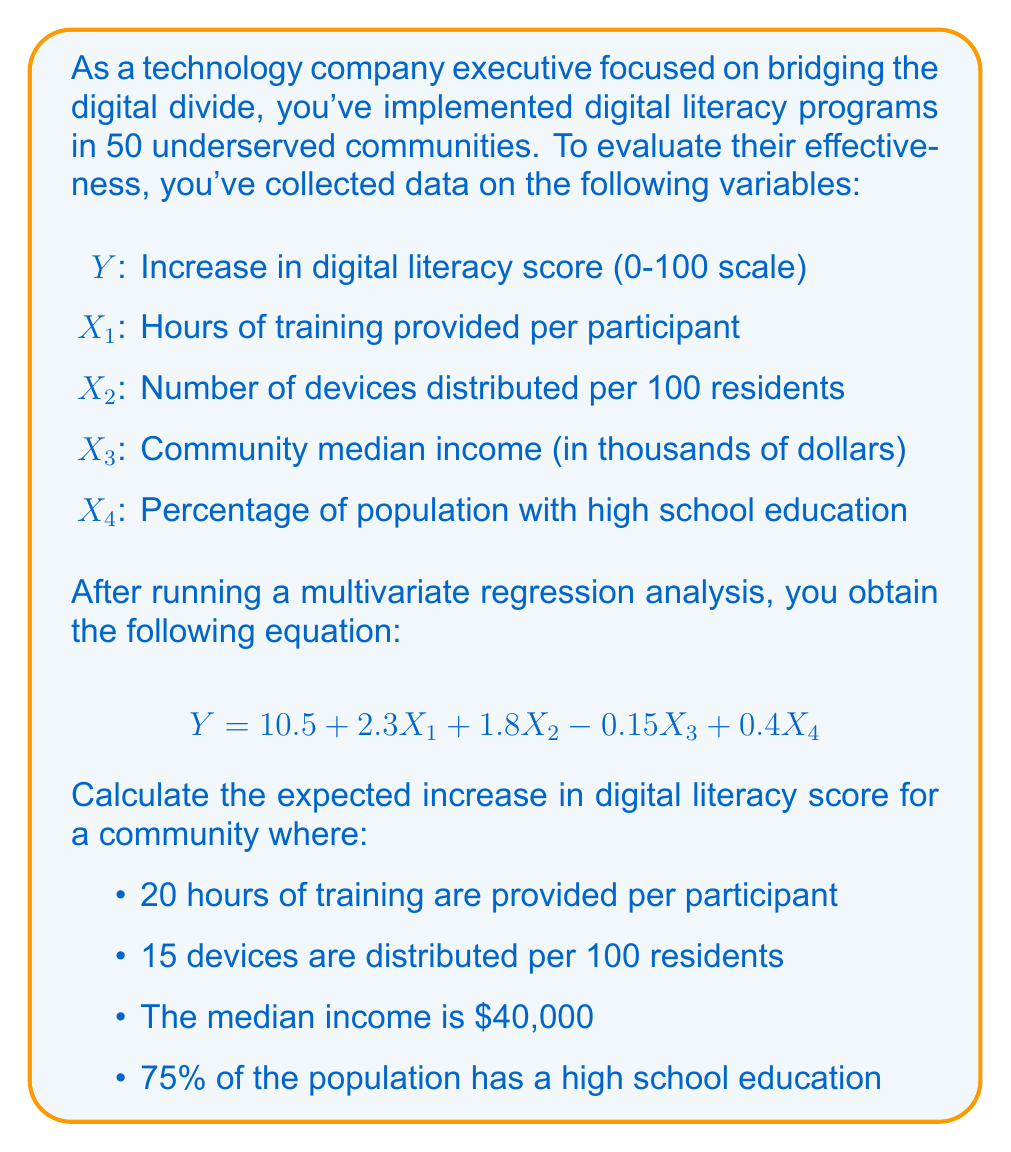Help me with this question. To solve this problem, we need to use the given multivariate regression equation and substitute the values for each variable. Let's break it down step by step:

1. The regression equation is:
   $$Y = 10.5 + 2.3X_1 + 1.8X_2 - 0.15X_3 + 0.4X_4$$

2. We have the following values:
   $X_1 = 20$ (hours of training)
   $X_2 = 15$ (devices per 100 residents)
   $X_3 = 40$ (median income in thousands)
   $X_4 = 75$ (percentage with high school education)

3. Let's substitute these values into the equation:

   $$Y = 10.5 + 2.3(20) + 1.8(15) - 0.15(40) + 0.4(75)$$

4. Now, let's calculate each term:
   - $10.5$ (constant term)
   - $2.3(20) = 46$
   - $1.8(15) = 27$
   - $-0.15(40) = -6$
   - $0.4(75) = 30$

5. Sum up all the terms:
   $$Y = 10.5 + 46 + 27 - 6 + 30$$

6. Calculate the final result:
   $$Y = 107.5$$
Answer: The expected increase in digital literacy score for the given community is 107.5 points. 